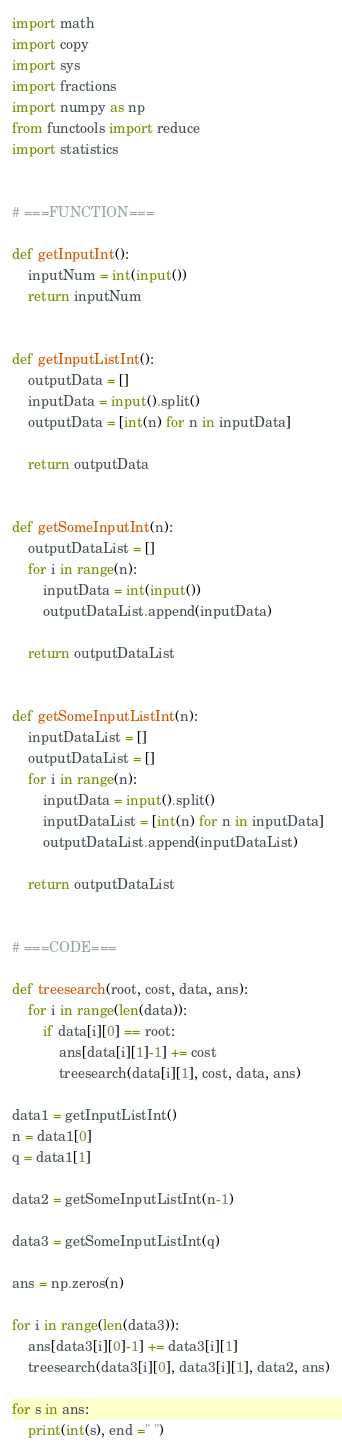Convert code to text. <code><loc_0><loc_0><loc_500><loc_500><_Python_>import math
import copy
import sys
import fractions
import numpy as np
from functools import reduce
import statistics


# ===FUNCTION===

def getInputInt():
    inputNum = int(input())
    return inputNum


def getInputListInt():
    outputData = []
    inputData = input().split()
    outputData = [int(n) for n in inputData]

    return outputData


def getSomeInputInt(n):
    outputDataList = []
    for i in range(n):
        inputData = int(input())
        outputDataList.append(inputData)

    return outputDataList


def getSomeInputListInt(n):
    inputDataList = []
    outputDataList = []
    for i in range(n):
        inputData = input().split()
        inputDataList = [int(n) for n in inputData]
        outputDataList.append(inputDataList)

    return outputDataList


# ===CODE===

def treesearch(root, cost, data, ans):
    for i in range(len(data)):
        if data[i][0] == root:
            ans[data[i][1]-1] += cost
            treesearch(data[i][1], cost, data, ans)

data1 = getInputListInt()
n = data1[0]
q = data1[1]

data2 = getSomeInputListInt(n-1)

data3 = getSomeInputListInt(q)

ans = np.zeros(n)

for i in range(len(data3)):
    ans[data3[i][0]-1] += data3[i][1]
    treesearch(data3[i][0], data3[i][1], data2, ans)

for s in ans:
    print(int(s), end =" ")

</code> 